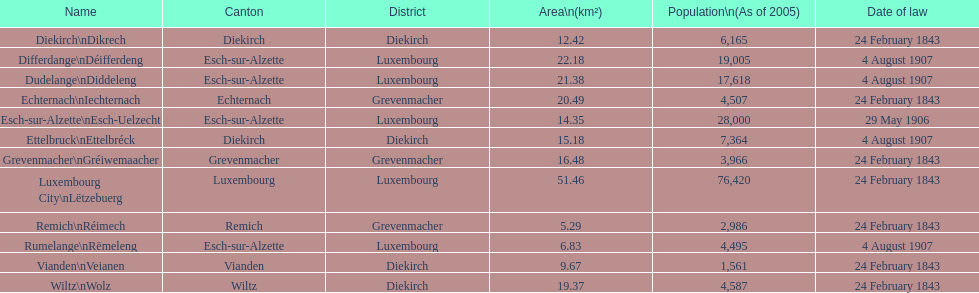Identifying the canton that is governed by the law enacted on february 24, 1843, and has a population totaling 3,966? Grevenmacher. 